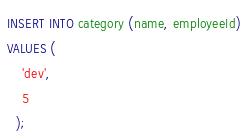Convert code to text. <code><loc_0><loc_0><loc_500><loc_500><_SQL_>INSERT INTO category (name, employeeId)
VALUES (
    'dev',
    5
  );</code> 